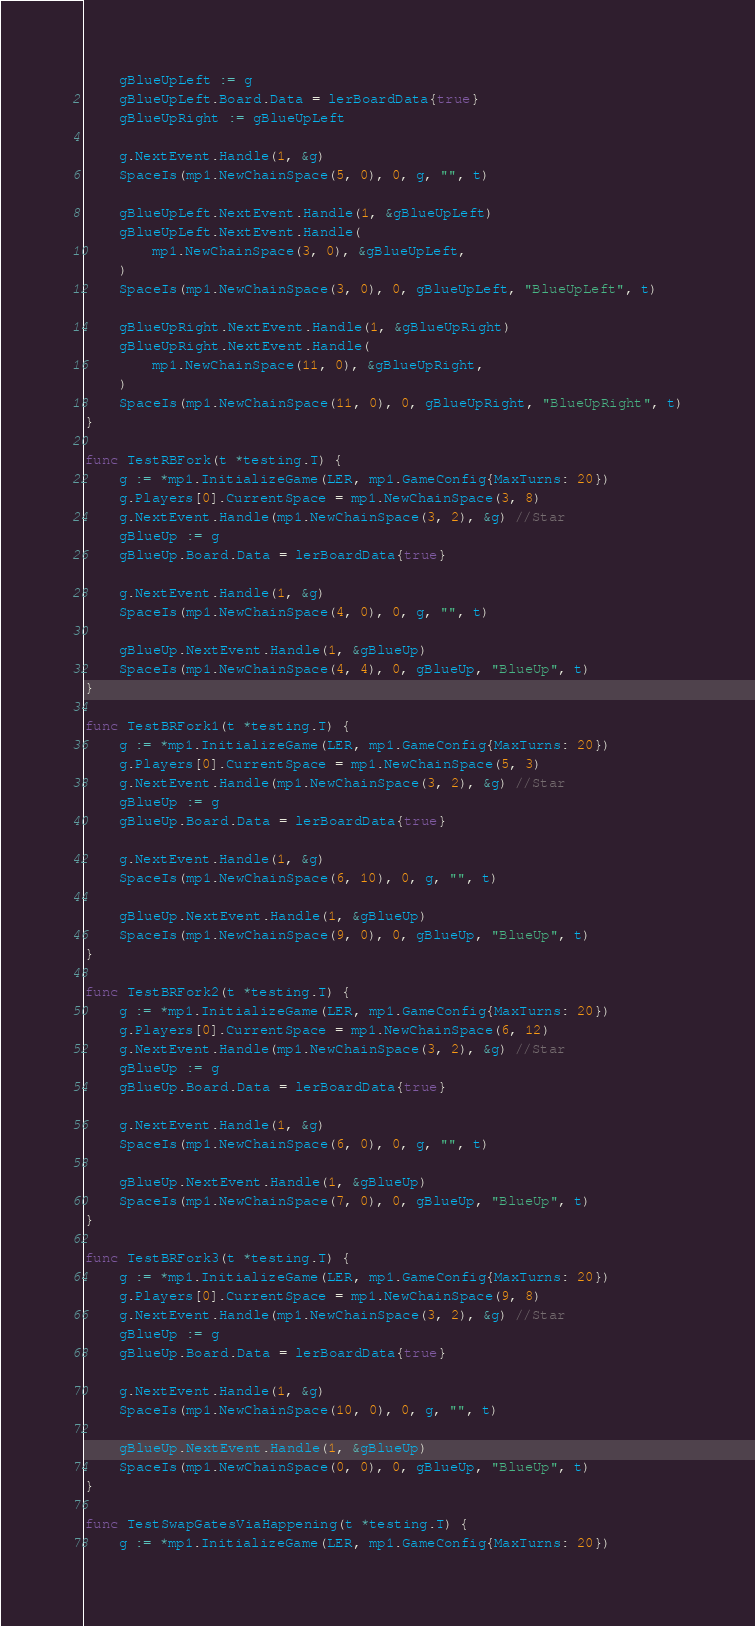<code> <loc_0><loc_0><loc_500><loc_500><_Go_>	gBlueUpLeft := g
	gBlueUpLeft.Board.Data = lerBoardData{true}
	gBlueUpRight := gBlueUpLeft

	g.NextEvent.Handle(1, &g)
	SpaceIs(mp1.NewChainSpace(5, 0), 0, g, "", t)

	gBlueUpLeft.NextEvent.Handle(1, &gBlueUpLeft)
	gBlueUpLeft.NextEvent.Handle(
		mp1.NewChainSpace(3, 0), &gBlueUpLeft,
	)
	SpaceIs(mp1.NewChainSpace(3, 0), 0, gBlueUpLeft, "BlueUpLeft", t)

	gBlueUpRight.NextEvent.Handle(1, &gBlueUpRight)
	gBlueUpRight.NextEvent.Handle(
		mp1.NewChainSpace(11, 0), &gBlueUpRight,
	)
	SpaceIs(mp1.NewChainSpace(11, 0), 0, gBlueUpRight, "BlueUpRight", t)
}

func TestRBFork(t *testing.T) {
	g := *mp1.InitializeGame(LER, mp1.GameConfig{MaxTurns: 20})
	g.Players[0].CurrentSpace = mp1.NewChainSpace(3, 8)
	g.NextEvent.Handle(mp1.NewChainSpace(3, 2), &g) //Star
	gBlueUp := g
	gBlueUp.Board.Data = lerBoardData{true}

	g.NextEvent.Handle(1, &g)
	SpaceIs(mp1.NewChainSpace(4, 0), 0, g, "", t)

	gBlueUp.NextEvent.Handle(1, &gBlueUp)
	SpaceIs(mp1.NewChainSpace(4, 4), 0, gBlueUp, "BlueUp", t)
}

func TestBRFork1(t *testing.T) {
	g := *mp1.InitializeGame(LER, mp1.GameConfig{MaxTurns: 20})
	g.Players[0].CurrentSpace = mp1.NewChainSpace(5, 3)
	g.NextEvent.Handle(mp1.NewChainSpace(3, 2), &g) //Star
	gBlueUp := g
	gBlueUp.Board.Data = lerBoardData{true}

	g.NextEvent.Handle(1, &g)
	SpaceIs(mp1.NewChainSpace(6, 10), 0, g, "", t)

	gBlueUp.NextEvent.Handle(1, &gBlueUp)
	SpaceIs(mp1.NewChainSpace(9, 0), 0, gBlueUp, "BlueUp", t)
}

func TestBRFork2(t *testing.T) {
	g := *mp1.InitializeGame(LER, mp1.GameConfig{MaxTurns: 20})
	g.Players[0].CurrentSpace = mp1.NewChainSpace(6, 12)
	g.NextEvent.Handle(mp1.NewChainSpace(3, 2), &g) //Star
	gBlueUp := g
	gBlueUp.Board.Data = lerBoardData{true}

	g.NextEvent.Handle(1, &g)
	SpaceIs(mp1.NewChainSpace(6, 0), 0, g, "", t)

	gBlueUp.NextEvent.Handle(1, &gBlueUp)
	SpaceIs(mp1.NewChainSpace(7, 0), 0, gBlueUp, "BlueUp", t)
}

func TestBRFork3(t *testing.T) {
	g := *mp1.InitializeGame(LER, mp1.GameConfig{MaxTurns: 20})
	g.Players[0].CurrentSpace = mp1.NewChainSpace(9, 8)
	g.NextEvent.Handle(mp1.NewChainSpace(3, 2), &g) //Star
	gBlueUp := g
	gBlueUp.Board.Data = lerBoardData{true}

	g.NextEvent.Handle(1, &g)
	SpaceIs(mp1.NewChainSpace(10, 0), 0, g, "", t)

	gBlueUp.NextEvent.Handle(1, &gBlueUp)
	SpaceIs(mp1.NewChainSpace(0, 0), 0, gBlueUp, "BlueUp", t)
}

func TestSwapGatesViaHappening(t *testing.T) {
	g := *mp1.InitializeGame(LER, mp1.GameConfig{MaxTurns: 20})</code> 